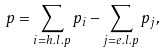Convert formula to latex. <formula><loc_0><loc_0><loc_500><loc_500>p = \sum _ { i = h . l . p } p _ { i } - \sum _ { j = e . l . p } p _ { j } ,</formula> 